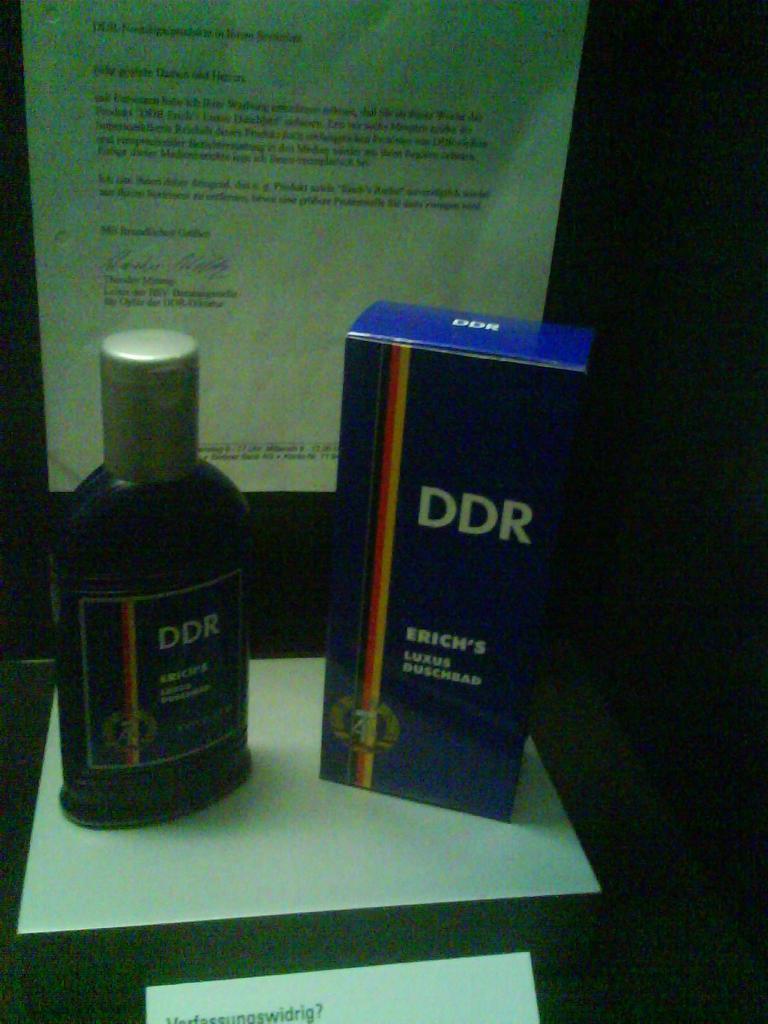How would you summarize this image in a sentence or two? In this picture I can see a bottle, box placed on the paper and also I can see a paper with some text. 